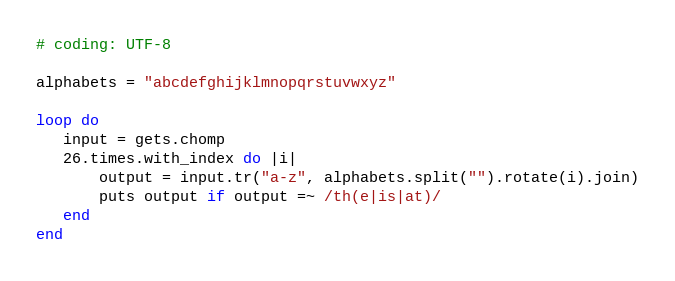Convert code to text. <code><loc_0><loc_0><loc_500><loc_500><_Ruby_># coding: UTF-8

alphabets = "abcdefghijklmnopqrstuvwxyz"

loop do
   input = gets.chomp
   26.times.with_index do |i|
       output = input.tr("a-z", alphabets.split("").rotate(i).join)
       puts output if output =~ /th(e|is|at)/
   end
end</code> 